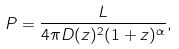Convert formula to latex. <formula><loc_0><loc_0><loc_500><loc_500>P = \frac { L } { 4 \pi D ( z ) ^ { 2 } ( 1 + z ) ^ { \alpha } } ,</formula> 